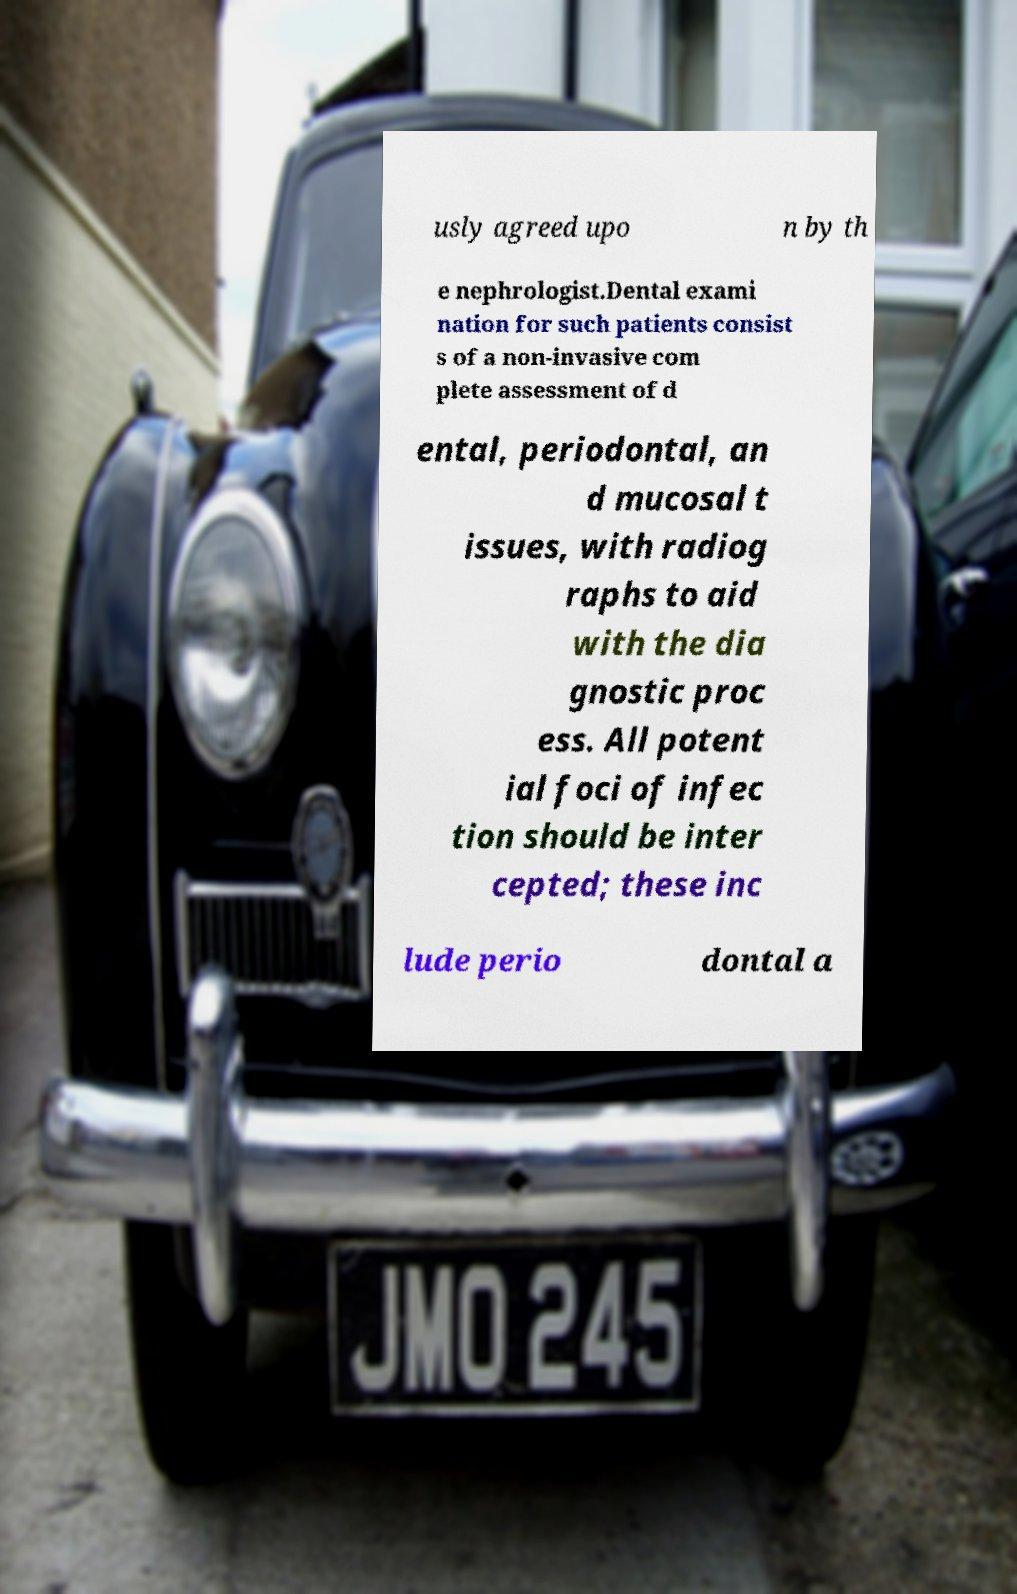There's text embedded in this image that I need extracted. Can you transcribe it verbatim? usly agreed upo n by th e nephrologist.Dental exami nation for such patients consist s of a non-invasive com plete assessment of d ental, periodontal, an d mucosal t issues, with radiog raphs to aid with the dia gnostic proc ess. All potent ial foci of infec tion should be inter cepted; these inc lude perio dontal a 